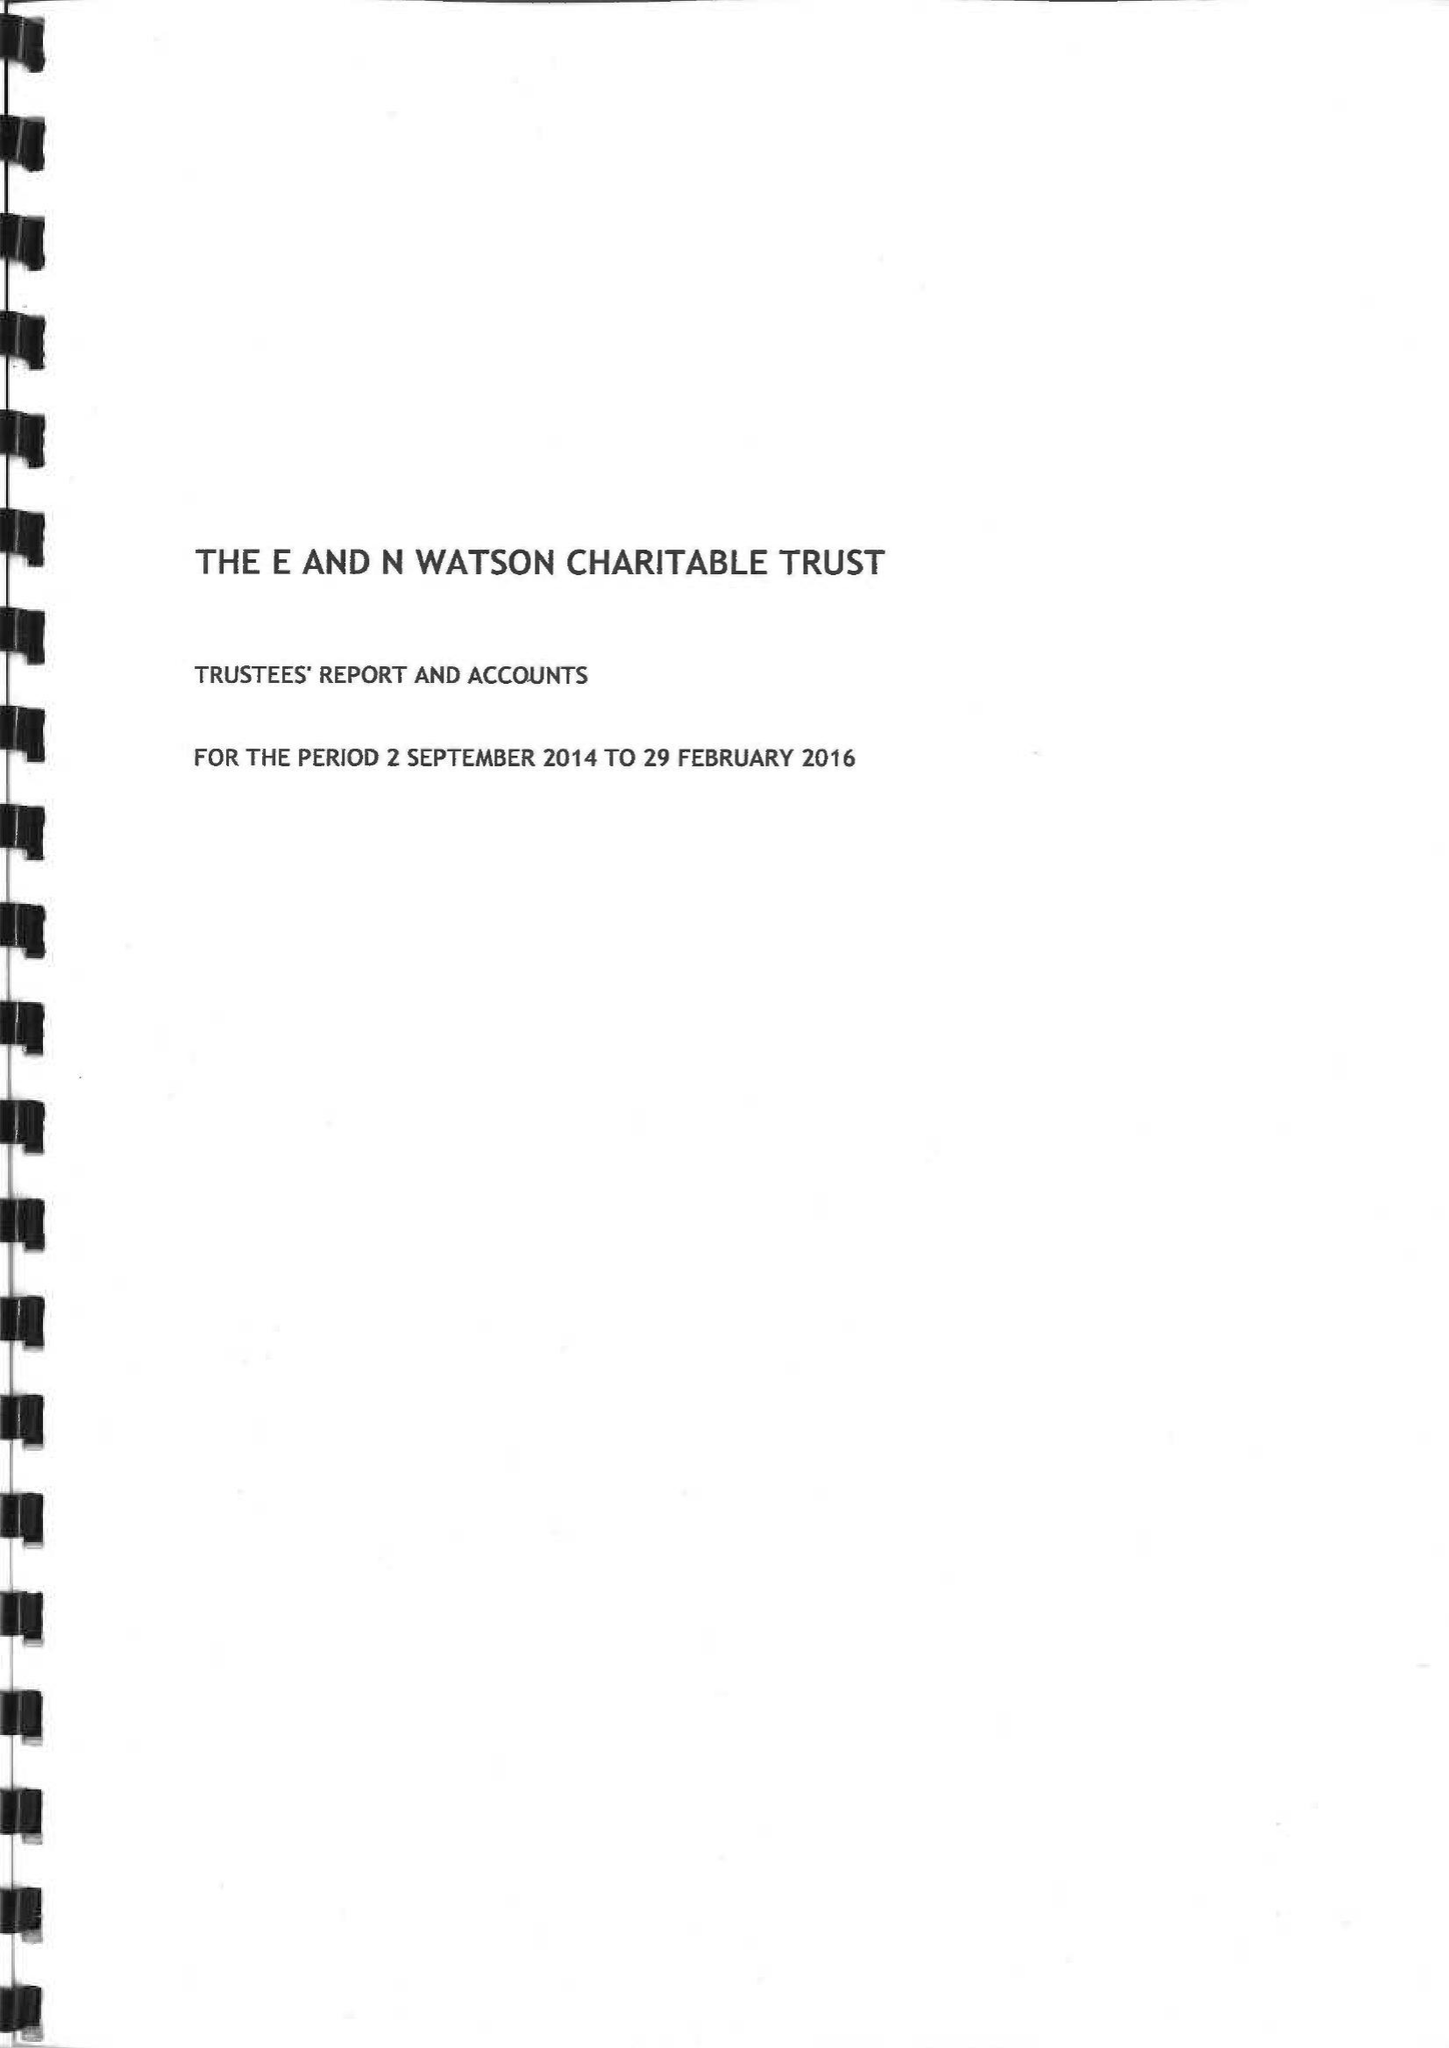What is the value for the report_date?
Answer the question using a single word or phrase. 2016-02-29 